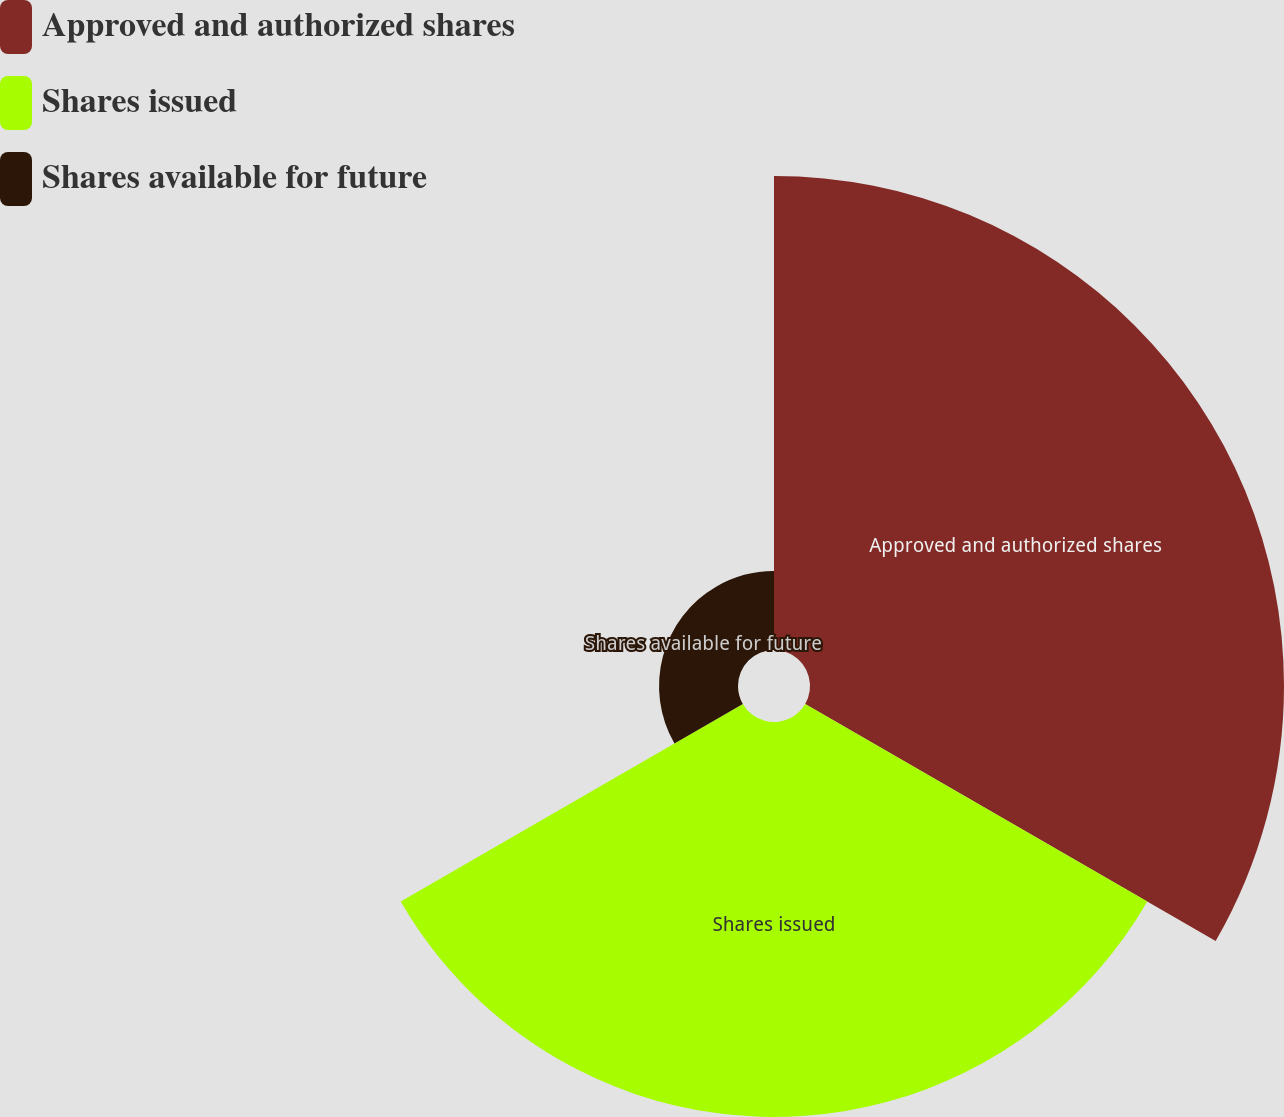Convert chart to OTSL. <chart><loc_0><loc_0><loc_500><loc_500><pie_chart><fcel>Approved and authorized shares<fcel>Shares issued<fcel>Shares available for future<nl><fcel>50.0%<fcel>41.67%<fcel>8.33%<nl></chart> 